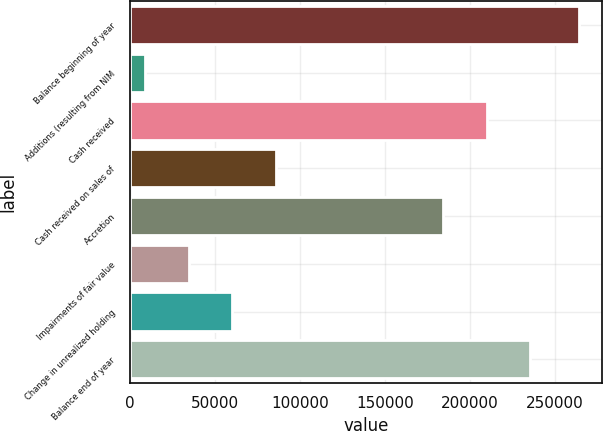Convert chart to OTSL. <chart><loc_0><loc_0><loc_500><loc_500><bar_chart><fcel>Balance beginning of year<fcel>Additions (resulting from NIM<fcel>Cash received<fcel>Cash received on sales of<fcel>Accretion<fcel>Impairments of fair value<fcel>Change in unrealized holding<fcel>Balance end of year<nl><fcel>264337<fcel>9007<fcel>209786<fcel>85606<fcel>184253<fcel>34540<fcel>60073<fcel>235319<nl></chart> 